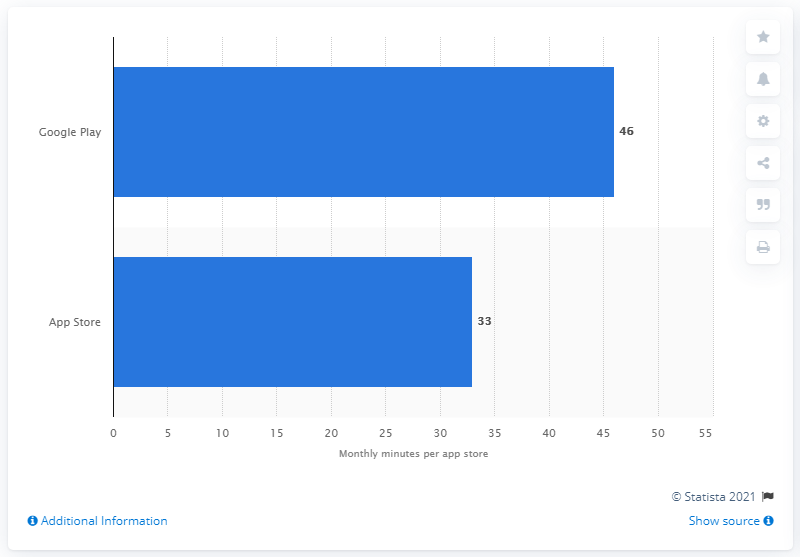Give some essential details in this illustration. In the month, Google Play users spent an average of 46 minutes per user at the app store. 